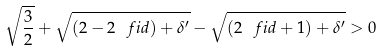<formula> <loc_0><loc_0><loc_500><loc_500>\sqrt { \frac { 3 } { 2 } } + \sqrt { ( 2 - 2 \ f i d ) + \delta ^ { \prime } } - \sqrt { ( 2 \ f i d + 1 ) + \delta ^ { \prime } } > 0</formula> 